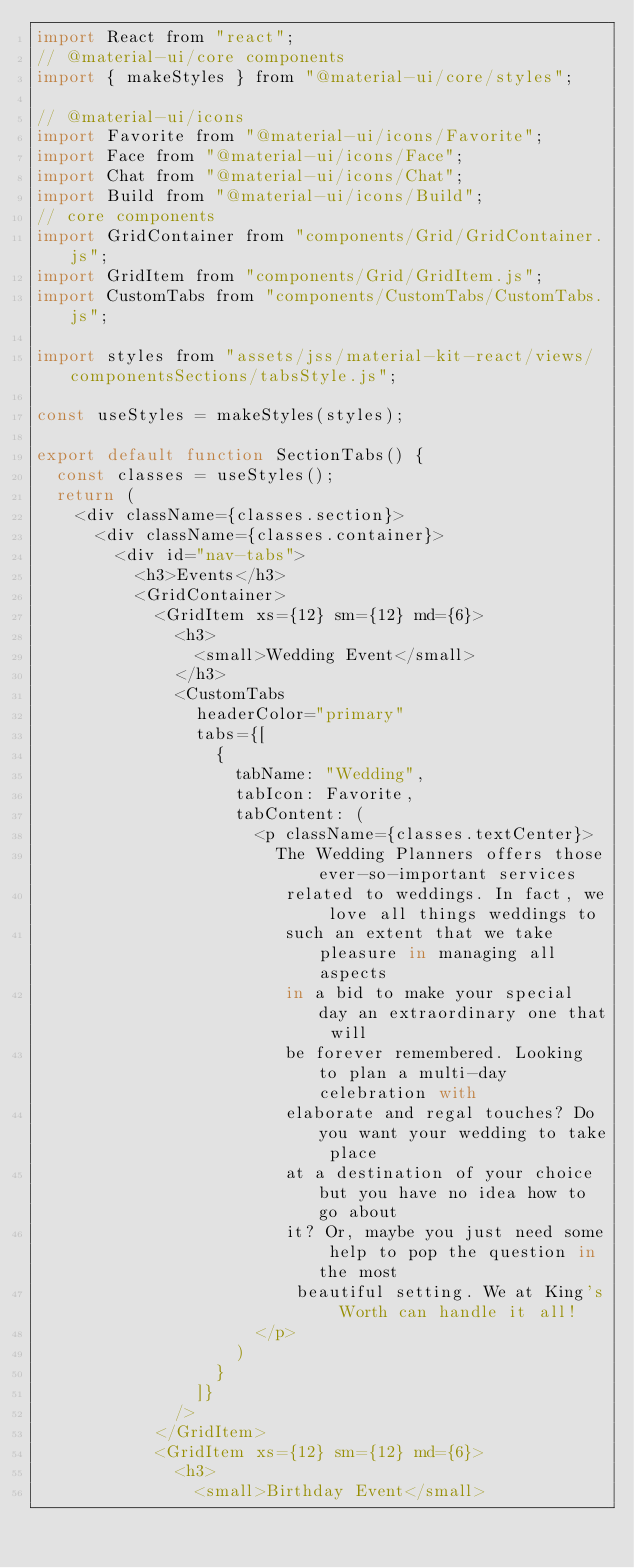<code> <loc_0><loc_0><loc_500><loc_500><_JavaScript_>import React from "react";
// @material-ui/core components
import { makeStyles } from "@material-ui/core/styles";

// @material-ui/icons
import Favorite from "@material-ui/icons/Favorite";
import Face from "@material-ui/icons/Face";
import Chat from "@material-ui/icons/Chat";
import Build from "@material-ui/icons/Build";
// core components
import GridContainer from "components/Grid/GridContainer.js";
import GridItem from "components/Grid/GridItem.js";
import CustomTabs from "components/CustomTabs/CustomTabs.js";

import styles from "assets/jss/material-kit-react/views/componentsSections/tabsStyle.js";

const useStyles = makeStyles(styles);

export default function SectionTabs() {
  const classes = useStyles();
  return (
    <div className={classes.section}>
      <div className={classes.container}>
        <div id="nav-tabs">
          <h3>Events</h3>
          <GridContainer>
            <GridItem xs={12} sm={12} md={6}>
              <h3>
                <small>Wedding Event</small>
              </h3>
              <CustomTabs
                headerColor="primary"
                tabs={[
                  {
                    tabName: "Wedding",
                    tabIcon: Favorite,
                    tabContent: (
                      <p className={classes.textCenter}>
                        The Wedding Planners offers those ever-so-important services
                         related to weddings. In fact, we love all things weddings to 
                         such an extent that we take pleasure in managing all aspects 
                         in a bid to make your special day an extraordinary one that will 
                         be forever remembered. Looking to plan a multi-day celebration with 
                         elaborate and regal touches? Do you want your wedding to take place 
                         at a destination of your choice but you have no idea how to go about 
                         it? Or, maybe you just need some help to pop the question in the most
                          beautiful setting. We at King's Worth can handle it all!
                      </p>
                    )
                  }                  
                ]}
              />
            </GridItem>
            <GridItem xs={12} sm={12} md={6}>
              <h3>
                <small>Birthday Event</small></code> 